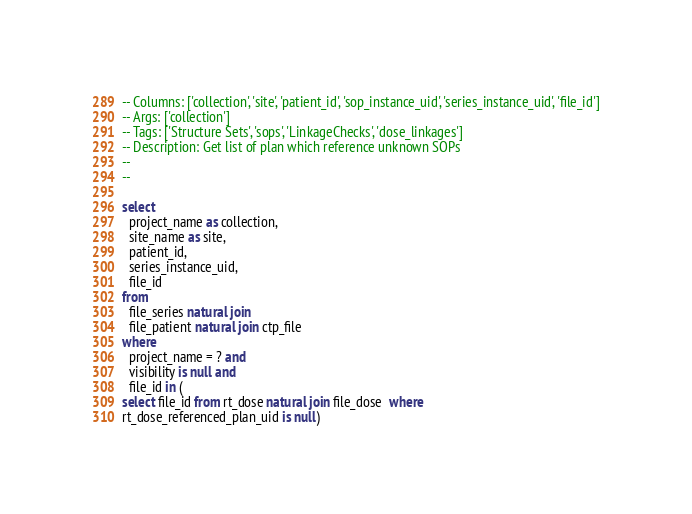<code> <loc_0><loc_0><loc_500><loc_500><_SQL_>-- Columns: ['collection', 'site', 'patient_id', 'sop_instance_uid', 'series_instance_uid', 'file_id']
-- Args: ['collection']
-- Tags: ['Structure Sets', 'sops', 'LinkageChecks', 'dose_linkages']
-- Description: Get list of plan which reference unknown SOPs
-- 
-- 

select
  project_name as collection,
  site_name as site,
  patient_id,
  series_instance_uid,
  file_id
from
  file_series natural join
  file_patient natural join ctp_file
where
  project_name = ? and
  visibility is null and
  file_id in (
select file_id from rt_dose natural join file_dose  where
rt_dose_referenced_plan_uid is null)</code> 